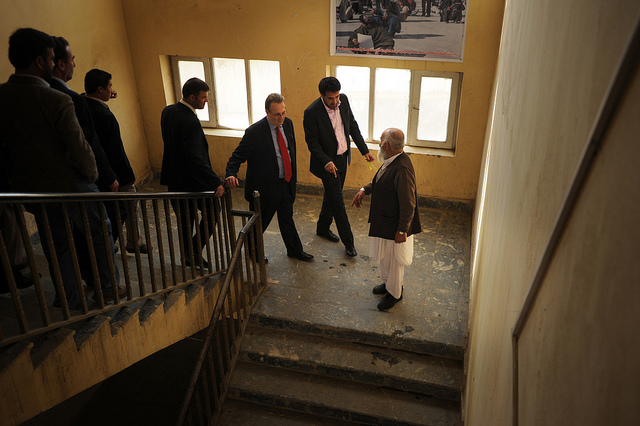<image>What pattern in on the shirt behind the cat? The pattern on the shirt behind the cat is not known. It could be solid, striped, or none at all. What pattern in on the shirt behind the cat? It is unknown what pattern is on the shirt behind the cat. There is no cat in the image. 